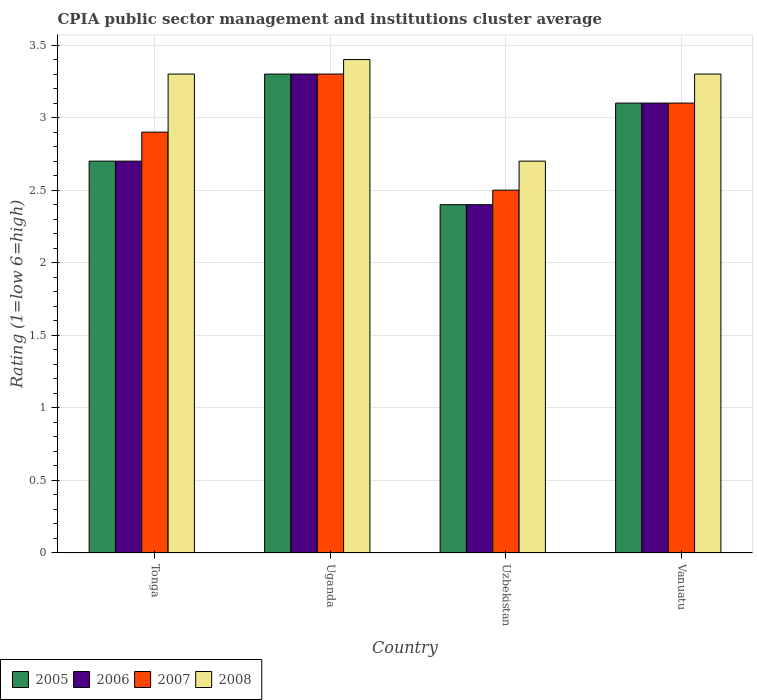How many different coloured bars are there?
Your answer should be very brief. 4. Are the number of bars on each tick of the X-axis equal?
Offer a very short reply. Yes. How many bars are there on the 2nd tick from the left?
Your response must be concise. 4. What is the label of the 3rd group of bars from the left?
Give a very brief answer. Uzbekistan. In how many cases, is the number of bars for a given country not equal to the number of legend labels?
Your answer should be compact. 0. What is the CPIA rating in 2007 in Uganda?
Ensure brevity in your answer.  3.3. Across all countries, what is the maximum CPIA rating in 2008?
Provide a succinct answer. 3.4. In which country was the CPIA rating in 2008 maximum?
Your answer should be very brief. Uganda. In which country was the CPIA rating in 2007 minimum?
Give a very brief answer. Uzbekistan. What is the total CPIA rating in 2008 in the graph?
Offer a terse response. 12.7. What is the difference between the CPIA rating in 2006 in Tonga and that in Vanuatu?
Provide a succinct answer. -0.4. What is the difference between the CPIA rating in 2006 in Vanuatu and the CPIA rating in 2007 in Uzbekistan?
Your answer should be compact. 0.6. What is the average CPIA rating in 2006 per country?
Offer a terse response. 2.88. What is the difference between the CPIA rating of/in 2007 and CPIA rating of/in 2005 in Tonga?
Give a very brief answer. 0.2. What is the ratio of the CPIA rating in 2007 in Uganda to that in Vanuatu?
Your answer should be compact. 1.06. Is the CPIA rating in 2007 in Tonga less than that in Vanuatu?
Offer a very short reply. Yes. What is the difference between the highest and the second highest CPIA rating in 2008?
Your answer should be compact. -0.1. What is the difference between the highest and the lowest CPIA rating in 2008?
Make the answer very short. 0.7. In how many countries, is the CPIA rating in 2005 greater than the average CPIA rating in 2005 taken over all countries?
Provide a succinct answer. 2. Is it the case that in every country, the sum of the CPIA rating in 2008 and CPIA rating in 2006 is greater than the sum of CPIA rating in 2007 and CPIA rating in 2005?
Offer a very short reply. No. What does the 1st bar from the left in Vanuatu represents?
Keep it short and to the point. 2005. What does the 3rd bar from the right in Uzbekistan represents?
Give a very brief answer. 2006. Is it the case that in every country, the sum of the CPIA rating in 2007 and CPIA rating in 2006 is greater than the CPIA rating in 2005?
Offer a very short reply. Yes. How many countries are there in the graph?
Make the answer very short. 4. What is the difference between two consecutive major ticks on the Y-axis?
Give a very brief answer. 0.5. Does the graph contain any zero values?
Make the answer very short. No. Does the graph contain grids?
Your answer should be very brief. Yes. Where does the legend appear in the graph?
Make the answer very short. Bottom left. How are the legend labels stacked?
Your answer should be compact. Horizontal. What is the title of the graph?
Offer a very short reply. CPIA public sector management and institutions cluster average. What is the label or title of the X-axis?
Your response must be concise. Country. What is the label or title of the Y-axis?
Make the answer very short. Rating (1=low 6=high). What is the Rating (1=low 6=high) in 2006 in Tonga?
Keep it short and to the point. 2.7. What is the Rating (1=low 6=high) in 2007 in Tonga?
Your answer should be very brief. 2.9. What is the Rating (1=low 6=high) in 2007 in Uganda?
Your response must be concise. 3.3. What is the Rating (1=low 6=high) of 2006 in Uzbekistan?
Provide a succinct answer. 2.4. What is the Rating (1=low 6=high) in 2007 in Uzbekistan?
Your answer should be very brief. 2.5. What is the Rating (1=low 6=high) in 2005 in Vanuatu?
Provide a short and direct response. 3.1. What is the Rating (1=low 6=high) in 2008 in Vanuatu?
Make the answer very short. 3.3. What is the total Rating (1=low 6=high) in 2007 in the graph?
Offer a very short reply. 11.8. What is the total Rating (1=low 6=high) in 2008 in the graph?
Provide a succinct answer. 12.7. What is the difference between the Rating (1=low 6=high) of 2005 in Tonga and that in Uzbekistan?
Your answer should be compact. 0.3. What is the difference between the Rating (1=low 6=high) in 2007 in Tonga and that in Vanuatu?
Your response must be concise. -0.2. What is the difference between the Rating (1=low 6=high) in 2008 in Tonga and that in Vanuatu?
Your response must be concise. 0. What is the difference between the Rating (1=low 6=high) in 2005 in Uganda and that in Uzbekistan?
Your answer should be compact. 0.9. What is the difference between the Rating (1=low 6=high) of 2006 in Uganda and that in Uzbekistan?
Give a very brief answer. 0.9. What is the difference between the Rating (1=low 6=high) of 2007 in Uganda and that in Uzbekistan?
Ensure brevity in your answer.  0.8. What is the difference between the Rating (1=low 6=high) in 2008 in Uganda and that in Uzbekistan?
Give a very brief answer. 0.7. What is the difference between the Rating (1=low 6=high) in 2005 in Uganda and that in Vanuatu?
Offer a very short reply. 0.2. What is the difference between the Rating (1=low 6=high) of 2006 in Uganda and that in Vanuatu?
Provide a short and direct response. 0.2. What is the difference between the Rating (1=low 6=high) of 2007 in Uganda and that in Vanuatu?
Ensure brevity in your answer.  0.2. What is the difference between the Rating (1=low 6=high) of 2007 in Uzbekistan and that in Vanuatu?
Your response must be concise. -0.6. What is the difference between the Rating (1=low 6=high) in 2005 in Tonga and the Rating (1=low 6=high) in 2006 in Uganda?
Your answer should be compact. -0.6. What is the difference between the Rating (1=low 6=high) of 2005 in Tonga and the Rating (1=low 6=high) of 2008 in Uganda?
Keep it short and to the point. -0.7. What is the difference between the Rating (1=low 6=high) in 2005 in Tonga and the Rating (1=low 6=high) in 2007 in Uzbekistan?
Make the answer very short. 0.2. What is the difference between the Rating (1=low 6=high) in 2005 in Tonga and the Rating (1=low 6=high) in 2006 in Vanuatu?
Your answer should be compact. -0.4. What is the difference between the Rating (1=low 6=high) of 2005 in Tonga and the Rating (1=low 6=high) of 2007 in Vanuatu?
Make the answer very short. -0.4. What is the difference between the Rating (1=low 6=high) in 2005 in Tonga and the Rating (1=low 6=high) in 2008 in Vanuatu?
Provide a succinct answer. -0.6. What is the difference between the Rating (1=low 6=high) of 2006 in Tonga and the Rating (1=low 6=high) of 2008 in Vanuatu?
Ensure brevity in your answer.  -0.6. What is the difference between the Rating (1=low 6=high) of 2007 in Tonga and the Rating (1=low 6=high) of 2008 in Vanuatu?
Offer a very short reply. -0.4. What is the difference between the Rating (1=low 6=high) in 2005 in Uganda and the Rating (1=low 6=high) in 2006 in Uzbekistan?
Your answer should be very brief. 0.9. What is the difference between the Rating (1=low 6=high) in 2005 in Uganda and the Rating (1=low 6=high) in 2008 in Uzbekistan?
Give a very brief answer. 0.6. What is the difference between the Rating (1=low 6=high) in 2006 in Uganda and the Rating (1=low 6=high) in 2008 in Uzbekistan?
Offer a terse response. 0.6. What is the difference between the Rating (1=low 6=high) of 2007 in Uganda and the Rating (1=low 6=high) of 2008 in Uzbekistan?
Ensure brevity in your answer.  0.6. What is the difference between the Rating (1=low 6=high) of 2005 in Uganda and the Rating (1=low 6=high) of 2008 in Vanuatu?
Offer a terse response. 0. What is the difference between the Rating (1=low 6=high) of 2005 in Uzbekistan and the Rating (1=low 6=high) of 2007 in Vanuatu?
Your response must be concise. -0.7. What is the difference between the Rating (1=low 6=high) of 2006 in Uzbekistan and the Rating (1=low 6=high) of 2007 in Vanuatu?
Your answer should be compact. -0.7. What is the difference between the Rating (1=low 6=high) of 2007 in Uzbekistan and the Rating (1=low 6=high) of 2008 in Vanuatu?
Your answer should be very brief. -0.8. What is the average Rating (1=low 6=high) in 2005 per country?
Your answer should be very brief. 2.88. What is the average Rating (1=low 6=high) of 2006 per country?
Make the answer very short. 2.88. What is the average Rating (1=low 6=high) in 2007 per country?
Give a very brief answer. 2.95. What is the average Rating (1=low 6=high) in 2008 per country?
Give a very brief answer. 3.17. What is the difference between the Rating (1=low 6=high) in 2005 and Rating (1=low 6=high) in 2006 in Tonga?
Your response must be concise. 0. What is the difference between the Rating (1=low 6=high) of 2005 and Rating (1=low 6=high) of 2008 in Tonga?
Make the answer very short. -0.6. What is the difference between the Rating (1=low 6=high) in 2006 and Rating (1=low 6=high) in 2008 in Tonga?
Provide a short and direct response. -0.6. What is the difference between the Rating (1=low 6=high) of 2007 and Rating (1=low 6=high) of 2008 in Tonga?
Provide a short and direct response. -0.4. What is the difference between the Rating (1=low 6=high) of 2005 and Rating (1=low 6=high) of 2007 in Uganda?
Offer a terse response. 0. What is the difference between the Rating (1=low 6=high) in 2006 and Rating (1=low 6=high) in 2007 in Uganda?
Give a very brief answer. 0. What is the difference between the Rating (1=low 6=high) of 2006 and Rating (1=low 6=high) of 2008 in Uzbekistan?
Make the answer very short. -0.3. What is the difference between the Rating (1=low 6=high) in 2005 and Rating (1=low 6=high) in 2008 in Vanuatu?
Offer a very short reply. -0.2. What is the difference between the Rating (1=low 6=high) in 2007 and Rating (1=low 6=high) in 2008 in Vanuatu?
Your answer should be very brief. -0.2. What is the ratio of the Rating (1=low 6=high) of 2005 in Tonga to that in Uganda?
Your answer should be compact. 0.82. What is the ratio of the Rating (1=low 6=high) in 2006 in Tonga to that in Uganda?
Your answer should be very brief. 0.82. What is the ratio of the Rating (1=low 6=high) in 2007 in Tonga to that in Uganda?
Ensure brevity in your answer.  0.88. What is the ratio of the Rating (1=low 6=high) in 2008 in Tonga to that in Uganda?
Keep it short and to the point. 0.97. What is the ratio of the Rating (1=low 6=high) of 2005 in Tonga to that in Uzbekistan?
Your answer should be very brief. 1.12. What is the ratio of the Rating (1=low 6=high) of 2007 in Tonga to that in Uzbekistan?
Your answer should be very brief. 1.16. What is the ratio of the Rating (1=low 6=high) in 2008 in Tonga to that in Uzbekistan?
Offer a terse response. 1.22. What is the ratio of the Rating (1=low 6=high) of 2005 in Tonga to that in Vanuatu?
Make the answer very short. 0.87. What is the ratio of the Rating (1=low 6=high) in 2006 in Tonga to that in Vanuatu?
Provide a succinct answer. 0.87. What is the ratio of the Rating (1=low 6=high) of 2007 in Tonga to that in Vanuatu?
Ensure brevity in your answer.  0.94. What is the ratio of the Rating (1=low 6=high) in 2005 in Uganda to that in Uzbekistan?
Give a very brief answer. 1.38. What is the ratio of the Rating (1=low 6=high) of 2006 in Uganda to that in Uzbekistan?
Offer a very short reply. 1.38. What is the ratio of the Rating (1=low 6=high) of 2007 in Uganda to that in Uzbekistan?
Your answer should be very brief. 1.32. What is the ratio of the Rating (1=low 6=high) in 2008 in Uganda to that in Uzbekistan?
Make the answer very short. 1.26. What is the ratio of the Rating (1=low 6=high) of 2005 in Uganda to that in Vanuatu?
Offer a terse response. 1.06. What is the ratio of the Rating (1=low 6=high) of 2006 in Uganda to that in Vanuatu?
Offer a terse response. 1.06. What is the ratio of the Rating (1=low 6=high) of 2007 in Uganda to that in Vanuatu?
Make the answer very short. 1.06. What is the ratio of the Rating (1=low 6=high) in 2008 in Uganda to that in Vanuatu?
Offer a very short reply. 1.03. What is the ratio of the Rating (1=low 6=high) of 2005 in Uzbekistan to that in Vanuatu?
Your answer should be compact. 0.77. What is the ratio of the Rating (1=low 6=high) in 2006 in Uzbekistan to that in Vanuatu?
Offer a very short reply. 0.77. What is the ratio of the Rating (1=low 6=high) in 2007 in Uzbekistan to that in Vanuatu?
Keep it short and to the point. 0.81. What is the ratio of the Rating (1=low 6=high) of 2008 in Uzbekistan to that in Vanuatu?
Give a very brief answer. 0.82. What is the difference between the highest and the second highest Rating (1=low 6=high) in 2005?
Offer a very short reply. 0.2. What is the difference between the highest and the second highest Rating (1=low 6=high) in 2008?
Your response must be concise. 0.1. What is the difference between the highest and the lowest Rating (1=low 6=high) in 2008?
Keep it short and to the point. 0.7. 